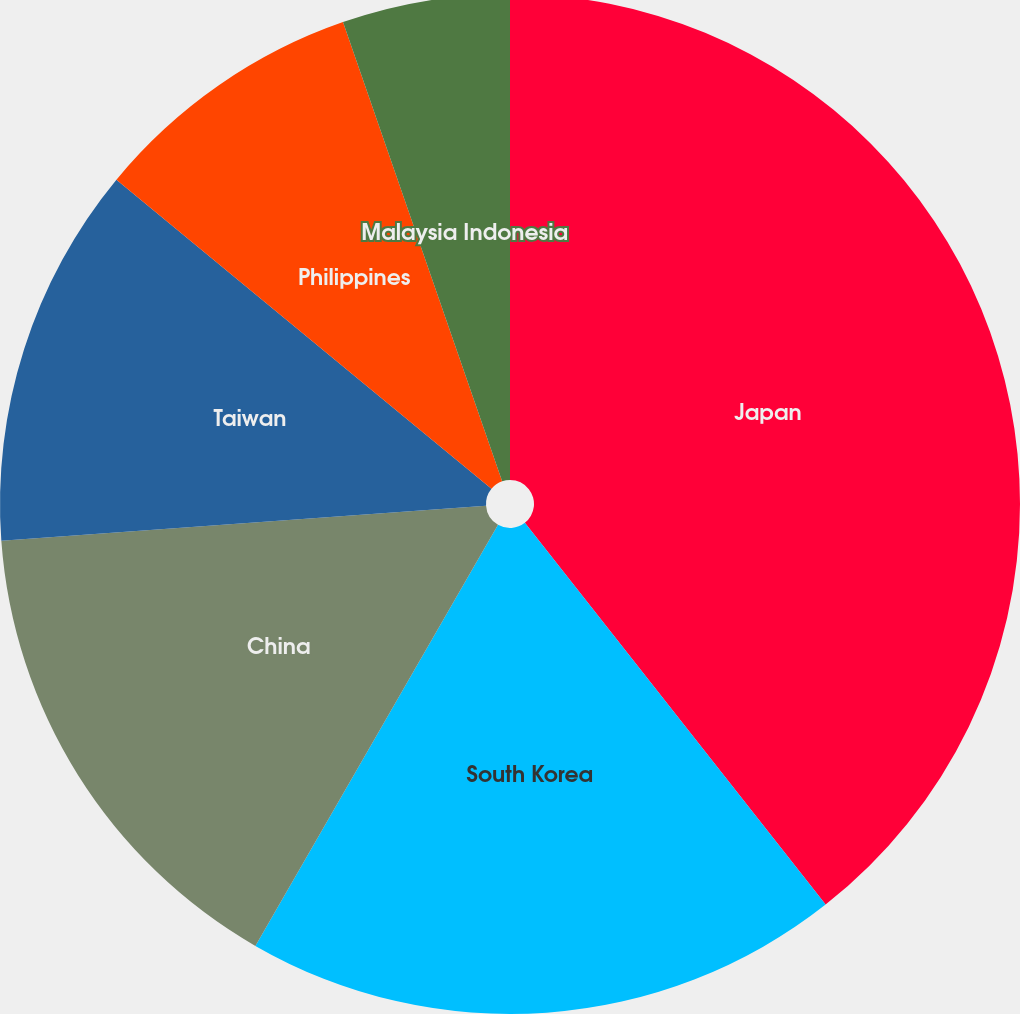Convert chart to OTSL. <chart><loc_0><loc_0><loc_500><loc_500><pie_chart><fcel>Japan<fcel>South Korea<fcel>China<fcel>Taiwan<fcel>Philippines<fcel>Malaysia Indonesia<nl><fcel>39.38%<fcel>18.94%<fcel>15.53%<fcel>12.12%<fcel>8.72%<fcel>5.31%<nl></chart> 